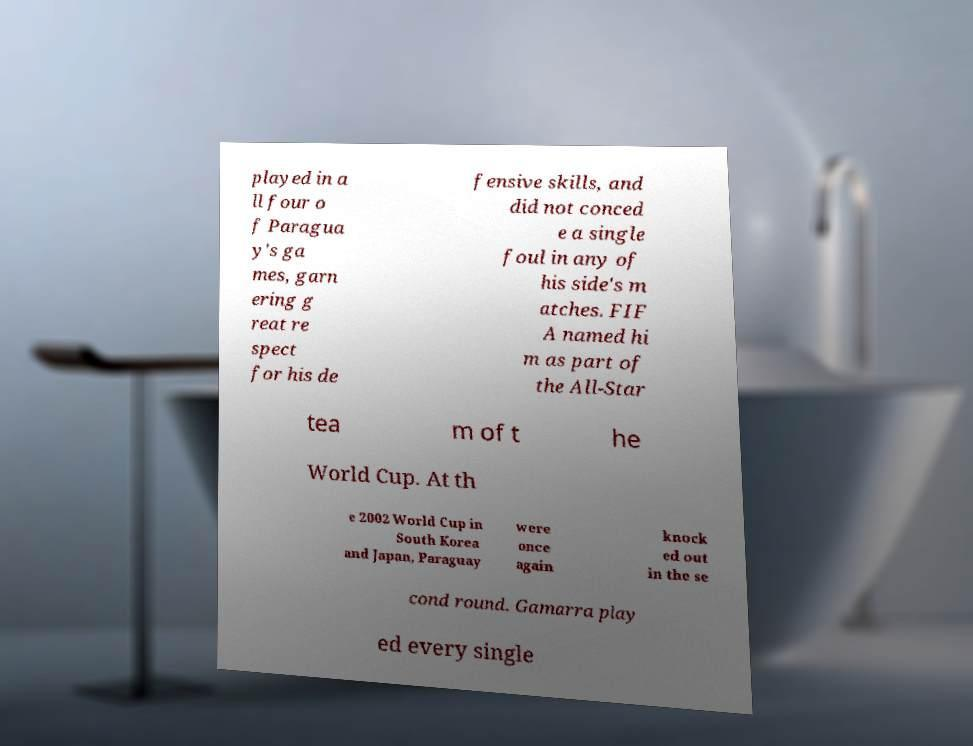Can you accurately transcribe the text from the provided image for me? played in a ll four o f Paragua y's ga mes, garn ering g reat re spect for his de fensive skills, and did not conced e a single foul in any of his side's m atches. FIF A named hi m as part of the All-Star tea m of t he World Cup. At th e 2002 World Cup in South Korea and Japan, Paraguay were once again knock ed out in the se cond round. Gamarra play ed every single 